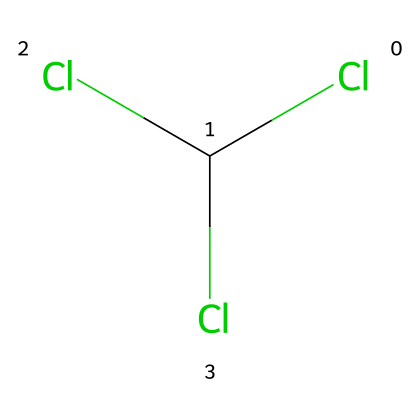What is the molecular formula of chloroform? The SMILES representation reveals that the structure contains one carbon atom (C) and three chlorine atoms (Cl), leading to the molecular formula CCl3H. However, the representation contains no hydrogen, so the correct formula considering the visible atoms is CCl4.
Answer: CCl4 How many chlorine atoms are present in chloroform? By examining the chemical structure from the SMILES string, there are three 'Cl' entries, indicating the presence of three chlorine atoms bonded to the carbon atom.
Answer: 3 What type of bonds are present in chloroform? The structure formed shows a carbon atom bonded to multiple chlorines via single bonds. In SMILES notation, there are no double or triple bond indicators, indicating all are single.
Answer: single bonds What hybridization is the carbon atom in chloroform? The carbon atom in chloroform is bonded to three chlorine atoms and is therefore considered to have a tetrahedral geometry, indicating sp3 hybridization. This can be inferred as there are four single bonds around the carbon atom.
Answer: sp3 Is chloroform polar or nonpolar? By analyzing the molecular structure, the presence of three highly electronegative chlorine atoms creates a significant dipole moment; therefore, chloroform does not have a symmetrical charge distribution and is polar.
Answer: polar What historical significance does chloroform have? Chloroform was used extensively as an anesthetic during the Civil War, allowing surgeons to perform painful procedures without causing pain to the patients. This historical context pertains to its important role in medical practices during that era.
Answer: anesthetic 